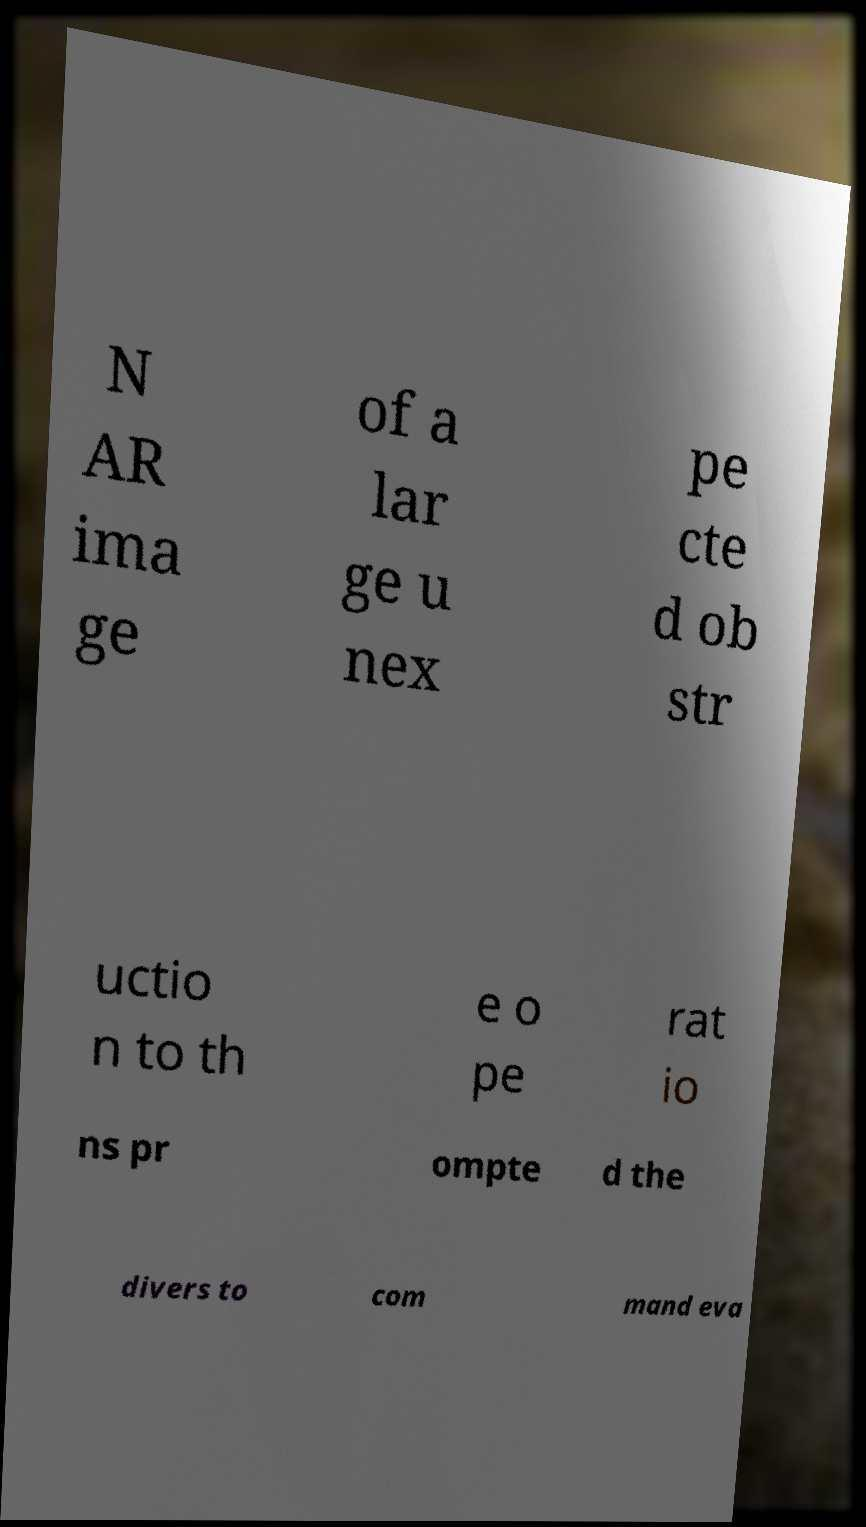There's text embedded in this image that I need extracted. Can you transcribe it verbatim? N AR ima ge of a lar ge u nex pe cte d ob str uctio n to th e o pe rat io ns pr ompte d the divers to com mand eva 